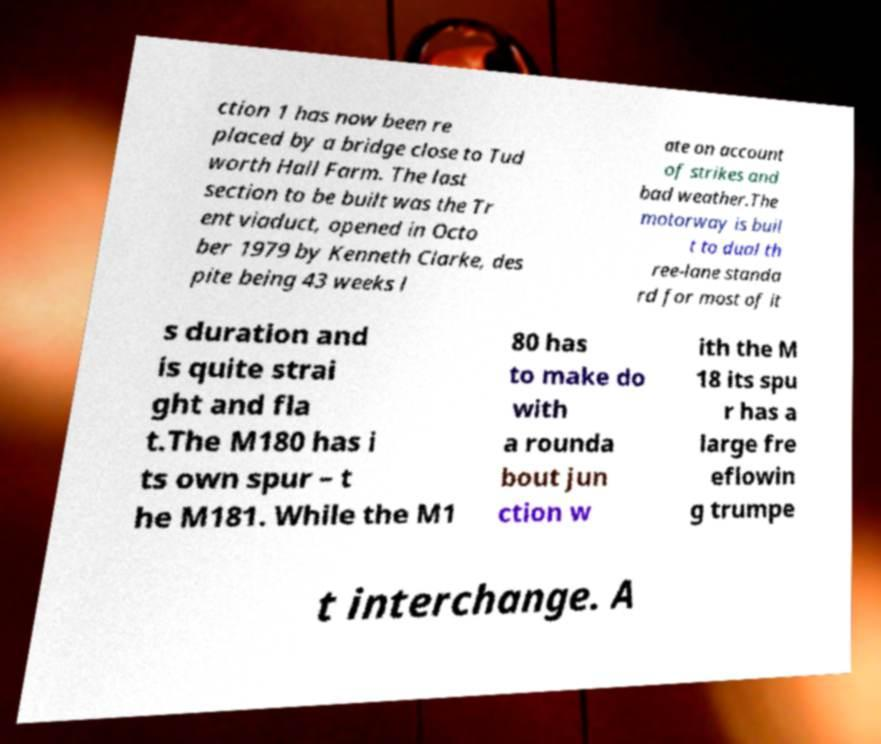For documentation purposes, I need the text within this image transcribed. Could you provide that? ction 1 has now been re placed by a bridge close to Tud worth Hall Farm. The last section to be built was the Tr ent viaduct, opened in Octo ber 1979 by Kenneth Clarke, des pite being 43 weeks l ate on account of strikes and bad weather.The motorway is buil t to dual th ree-lane standa rd for most of it s duration and is quite strai ght and fla t.The M180 has i ts own spur – t he M181. While the M1 80 has to make do with a rounda bout jun ction w ith the M 18 its spu r has a large fre eflowin g trumpe t interchange. A 